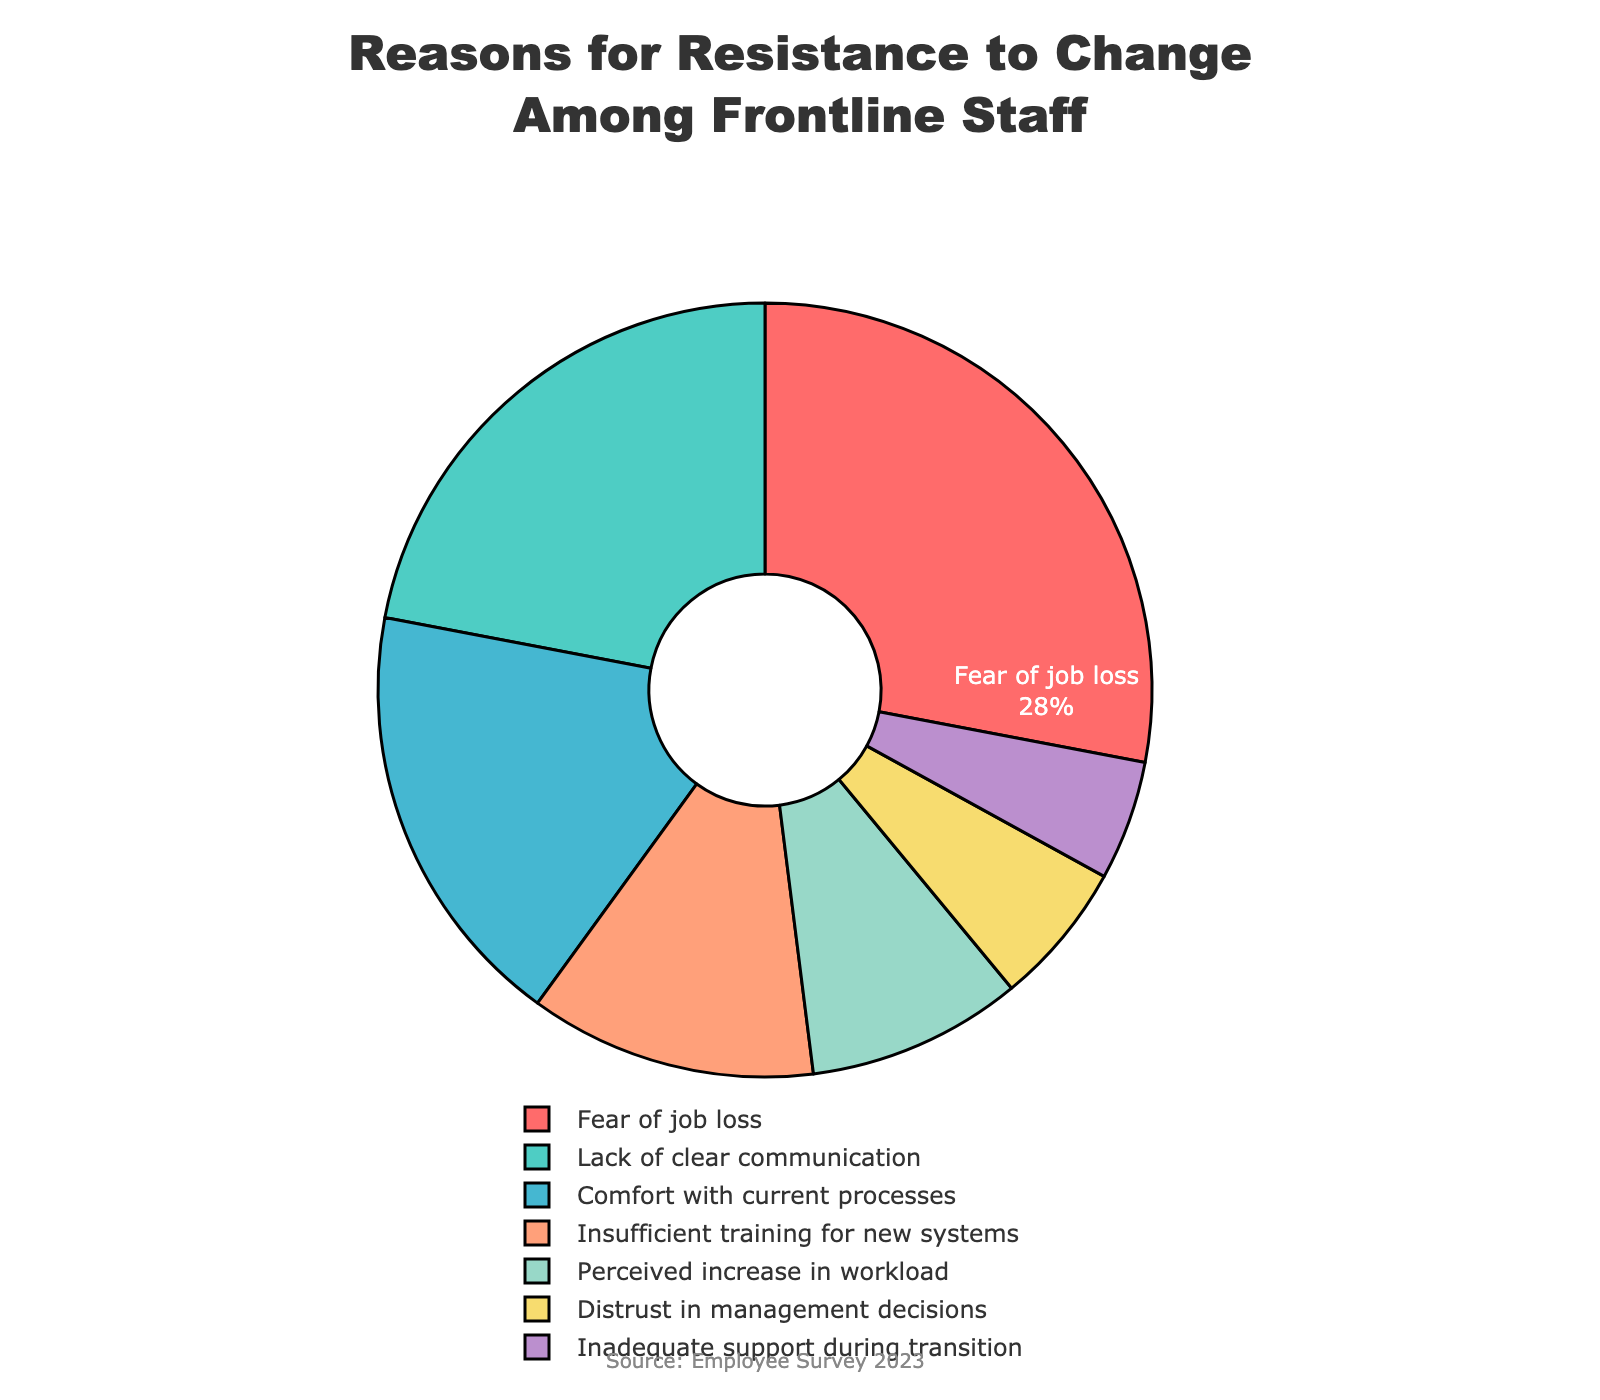How many reasons listed have a percentage of 10% or greater? From the pie chart, we can see the percentages for each reason. "Fear of job loss" (28%), "Lack of clear communication" (22%), "Comfort with current processes" (18%), and "Insufficient training for new systems" (12%) are all 10% or greater. That totals to 4 reasons.
Answer: 4 Which reason accounts for the smallest percentage of resistance to change? Examining the pie chart, we see that "Inadequate support during transition" accounts for the smallest portion with 5%.
Answer: Inadequate support during transition What is the combined percentage of "Fear of job loss" and "Lack of clear communication"? "Fear of job loss" is 28% and "Lack of clear communication" is 22%. Adding these together, 28% + 22% = 50%.
Answer: 50% Which reason is represented with the color green? By looking at the colors in the pie chart, we can identify that "Lack of clear communication" is shown in green.
Answer: Lack of clear communication Compare the percentage of "Insufficient training for new systems" to "Distrust in management decisions". Which one is higher and by how much? "Insufficient training for new systems" is 12%, while "Distrust in management decisions" is 6%. The difference can be calculated as 12% - 6% = 6%.
Answer: Insufficient training for new systems by 6% What is the total percentage of reasons related to communication and support ("Lack of clear communication" and "Inadequate support during transition")? "Lack of clear communication" is 22% and "Inadequate support during transition" is 5%, adding them together gives 22% + 5% = 27%.
Answer: 27% How does the percentage of "Perceived increase in workload" compare to "Distrust in management decisions"? "Perceived increase in workload" is 9% and "Distrust in management decisions" is 6%. 9% is greater than 6%.
Answer: Perceived increase in workload is higher What is the difference between the largest and smallest percentage reasons? The largest is "Fear of job loss" at 28%, and the smallest is "Inadequate support during transition" at 5%. The difference is 28% - 5% = 23%.
Answer: 23% 